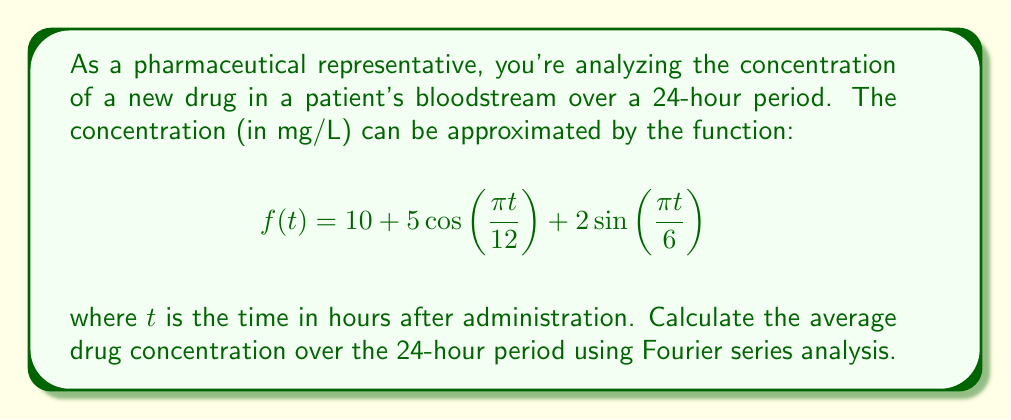Provide a solution to this math problem. To solve this problem, we'll follow these steps:

1) Recognize that the given function is already in the form of a Fourier series with a period of 24 hours.

2) Recall that the average value of a periodic function over one period is equal to the constant term (a₀) in its Fourier series representation.

3) In the general form of a Fourier series:

   $$f(t) = \frac{a_0}{2} + \sum_{n=1}^{\infty} \left(a_n \cos(\frac{2\pi nt}{T}) + b_n \sin(\frac{2\pi nt}{T})\right)$$

   where T is the period.

4) Comparing our function to this general form:

   $$f(t) = 10 + 5\cos(\frac{\pi t}{12}) + 2\sin(\frac{\pi t}{6})$$

   We can see that:
   - $\frac{a_0}{2} = 10$
   - The cosine term has $n=1$ and $T=24$
   - The sine term has $n=2$ and $T=24$

5) Therefore, $a_0 = 2 * 10 = 20$

6) The average concentration over the 24-hour period is simply $a_0/2 = 10$ mg/L.

This result makes intuitive sense as it's the constant term in the original function, around which the concentration oscillates due to the periodic terms.
Answer: The average drug concentration over the 24-hour period is 10 mg/L. 